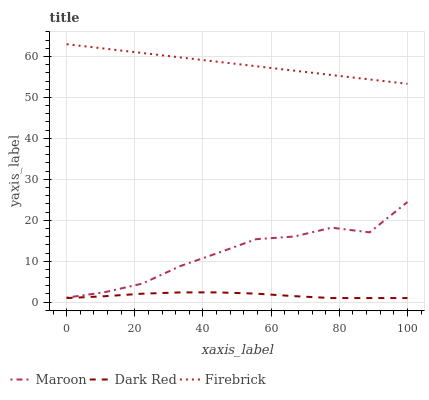Does Dark Red have the minimum area under the curve?
Answer yes or no. Yes. Does Firebrick have the maximum area under the curve?
Answer yes or no. Yes. Does Maroon have the minimum area under the curve?
Answer yes or no. No. Does Maroon have the maximum area under the curve?
Answer yes or no. No. Is Firebrick the smoothest?
Answer yes or no. Yes. Is Maroon the roughest?
Answer yes or no. Yes. Is Maroon the smoothest?
Answer yes or no. No. Is Firebrick the roughest?
Answer yes or no. No. Does Dark Red have the lowest value?
Answer yes or no. Yes. Does Maroon have the lowest value?
Answer yes or no. No. Does Firebrick have the highest value?
Answer yes or no. Yes. Does Maroon have the highest value?
Answer yes or no. No. Is Dark Red less than Firebrick?
Answer yes or no. Yes. Is Maroon greater than Dark Red?
Answer yes or no. Yes. Does Dark Red intersect Firebrick?
Answer yes or no. No. 